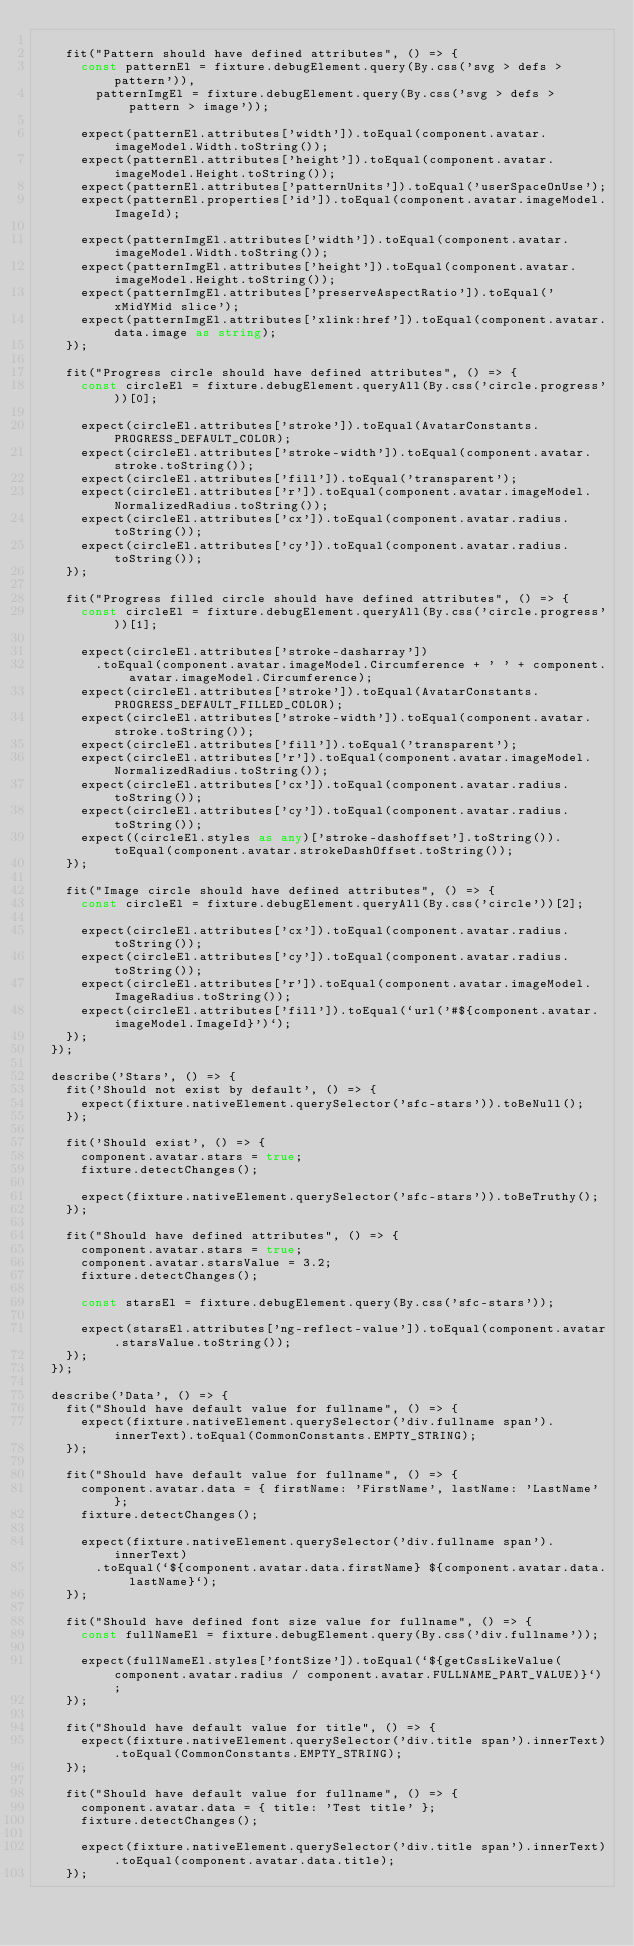Convert code to text. <code><loc_0><loc_0><loc_500><loc_500><_TypeScript_>
    fit("Pattern should have defined attributes", () => {
      const patternEl = fixture.debugElement.query(By.css('svg > defs > pattern')),
        patternImgEl = fixture.debugElement.query(By.css('svg > defs > pattern > image'));

      expect(patternEl.attributes['width']).toEqual(component.avatar.imageModel.Width.toString());
      expect(patternEl.attributes['height']).toEqual(component.avatar.imageModel.Height.toString());
      expect(patternEl.attributes['patternUnits']).toEqual('userSpaceOnUse');
      expect(patternEl.properties['id']).toEqual(component.avatar.imageModel.ImageId);

      expect(patternImgEl.attributes['width']).toEqual(component.avatar.imageModel.Width.toString());
      expect(patternImgEl.attributes['height']).toEqual(component.avatar.imageModel.Height.toString());
      expect(patternImgEl.attributes['preserveAspectRatio']).toEqual('xMidYMid slice');
      expect(patternImgEl.attributes['xlink:href']).toEqual(component.avatar.data.image as string);
    });

    fit("Progress circle should have defined attributes", () => {
      const circleEl = fixture.debugElement.queryAll(By.css('circle.progress'))[0];

      expect(circleEl.attributes['stroke']).toEqual(AvatarConstants.PROGRESS_DEFAULT_COLOR);
      expect(circleEl.attributes['stroke-width']).toEqual(component.avatar.stroke.toString());
      expect(circleEl.attributes['fill']).toEqual('transparent');
      expect(circleEl.attributes['r']).toEqual(component.avatar.imageModel.NormalizedRadius.toString());
      expect(circleEl.attributes['cx']).toEqual(component.avatar.radius.toString());
      expect(circleEl.attributes['cy']).toEqual(component.avatar.radius.toString());
    });

    fit("Progress filled circle should have defined attributes", () => {
      const circleEl = fixture.debugElement.queryAll(By.css('circle.progress'))[1];

      expect(circleEl.attributes['stroke-dasharray'])
        .toEqual(component.avatar.imageModel.Circumference + ' ' + component.avatar.imageModel.Circumference);
      expect(circleEl.attributes['stroke']).toEqual(AvatarConstants.PROGRESS_DEFAULT_FILLED_COLOR);
      expect(circleEl.attributes['stroke-width']).toEqual(component.avatar.stroke.toString());
      expect(circleEl.attributes['fill']).toEqual('transparent');
      expect(circleEl.attributes['r']).toEqual(component.avatar.imageModel.NormalizedRadius.toString());
      expect(circleEl.attributes['cx']).toEqual(component.avatar.radius.toString());
      expect(circleEl.attributes['cy']).toEqual(component.avatar.radius.toString());
      expect((circleEl.styles as any)['stroke-dashoffset'].toString()).toEqual(component.avatar.strokeDashOffset.toString());
    });

    fit("Image circle should have defined attributes", () => {
      const circleEl = fixture.debugElement.queryAll(By.css('circle'))[2];

      expect(circleEl.attributes['cx']).toEqual(component.avatar.radius.toString());
      expect(circleEl.attributes['cy']).toEqual(component.avatar.radius.toString());
      expect(circleEl.attributes['r']).toEqual(component.avatar.imageModel.ImageRadius.toString());
      expect(circleEl.attributes['fill']).toEqual(`url('#${component.avatar.imageModel.ImageId}')`);
    });
  });

  describe('Stars', () => {
    fit('Should not exist by default', () => {
      expect(fixture.nativeElement.querySelector('sfc-stars')).toBeNull();
    });

    fit('Should exist', () => {
      component.avatar.stars = true;
      fixture.detectChanges();

      expect(fixture.nativeElement.querySelector('sfc-stars')).toBeTruthy();
    });

    fit("Should have defined attributes", () => {
      component.avatar.stars = true;
      component.avatar.starsValue = 3.2;
      fixture.detectChanges();

      const starsEl = fixture.debugElement.query(By.css('sfc-stars'));

      expect(starsEl.attributes['ng-reflect-value']).toEqual(component.avatar.starsValue.toString());
    });
  });

  describe('Data', () => {
    fit("Should have default value for fullname", () => {
      expect(fixture.nativeElement.querySelector('div.fullname span').innerText).toEqual(CommonConstants.EMPTY_STRING);
    });

    fit("Should have default value for fullname", () => {
      component.avatar.data = { firstName: 'FirstName', lastName: 'LastName' };
      fixture.detectChanges();

      expect(fixture.nativeElement.querySelector('div.fullname span').innerText)
        .toEqual(`${component.avatar.data.firstName} ${component.avatar.data.lastName}`);
    });

    fit("Should have defined font size value for fullname", () => {
      const fullNameEl = fixture.debugElement.query(By.css('div.fullname'));

      expect(fullNameEl.styles['fontSize']).toEqual(`${getCssLikeValue(component.avatar.radius / component.avatar.FULLNAME_PART_VALUE)}`);
    });

    fit("Should have default value for title", () => {
      expect(fixture.nativeElement.querySelector('div.title span').innerText).toEqual(CommonConstants.EMPTY_STRING);
    });

    fit("Should have default value for fullname", () => {
      component.avatar.data = { title: 'Test title' };
      fixture.detectChanges();

      expect(fixture.nativeElement.querySelector('div.title span').innerText).toEqual(component.avatar.data.title);
    });
</code> 